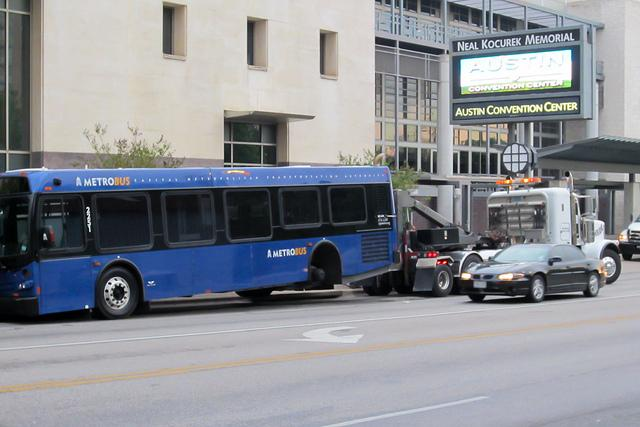In which state is this bus being towed? texas 